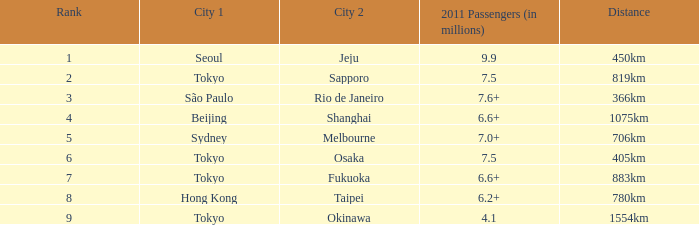Which city precedes okinawa when it is positioned as the second city? Tokyo. 